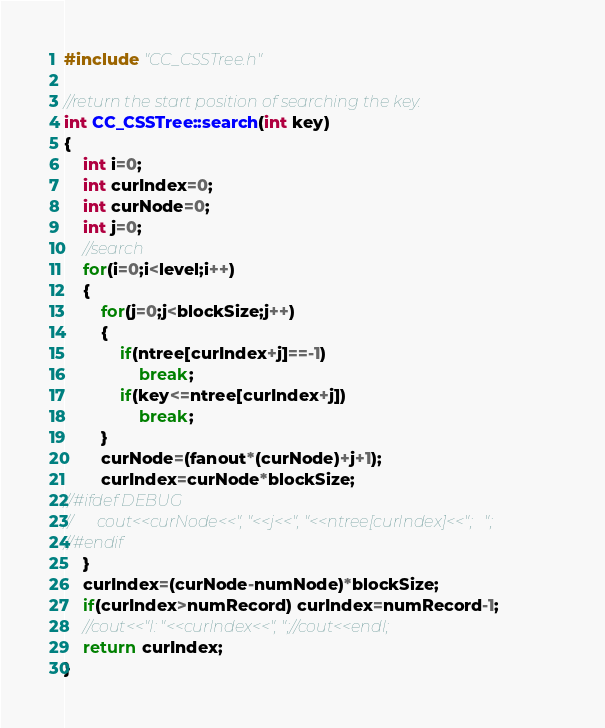<code> <loc_0><loc_0><loc_500><loc_500><_Cuda_>#include "CC_CSSTree.h"

//return the start position of searching the key.
int CC_CSSTree::search(int key)
{
	int i=0;
	int curIndex=0;
	int curNode=0;
	int j=0;
	//search
	for(i=0;i<level;i++)
	{
		for(j=0;j<blockSize;j++)
		{
			if(ntree[curIndex+j]==-1)
				break;
			if(key<=ntree[curIndex+j])
				break;
		}
		curNode=(fanout*(curNode)+j+1);
		curIndex=curNode*blockSize;
//#ifdef DEBUG
//		cout<<curNode<<", "<<j<<", "<<ntree[curIndex]<<";   ";
//#endif
	}
	curIndex=(curNode-numNode)*blockSize;
	if(curIndex>numRecord) curIndex=numRecord-1;
	//cout<<"I: "<<curIndex<<", ";//cout<<endl;
	return curIndex;
}
</code> 